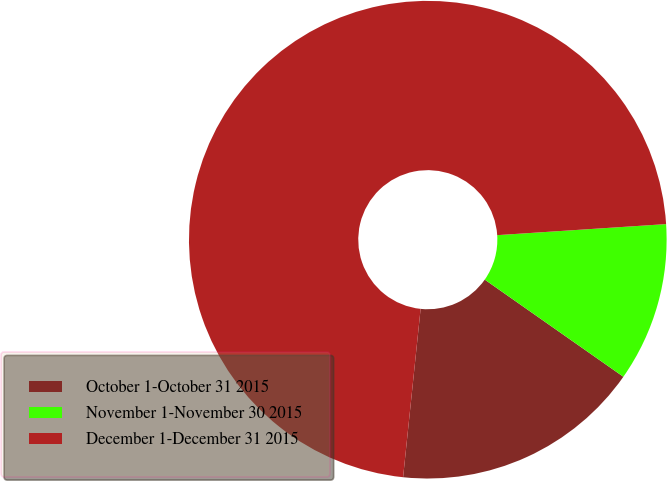Convert chart to OTSL. <chart><loc_0><loc_0><loc_500><loc_500><pie_chart><fcel>October 1-October 31 2015<fcel>November 1-November 30 2015<fcel>December 1-December 31 2015<nl><fcel>16.92%<fcel>10.77%<fcel>72.31%<nl></chart> 